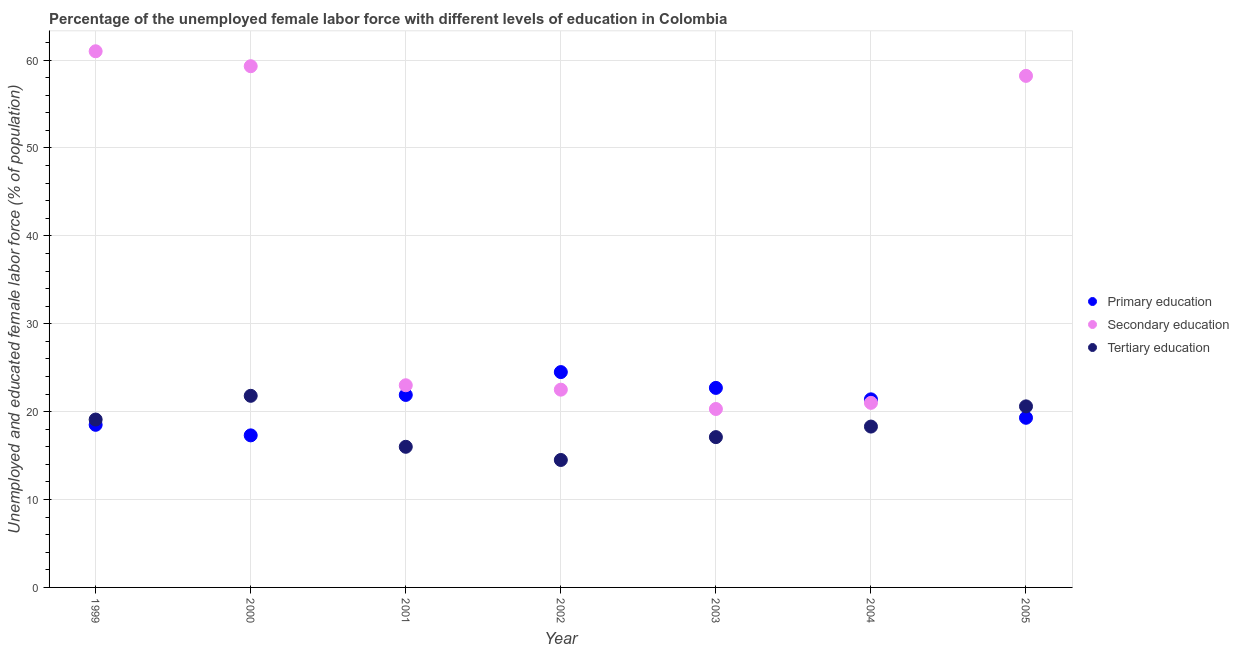How many different coloured dotlines are there?
Provide a succinct answer. 3. Is the number of dotlines equal to the number of legend labels?
Provide a succinct answer. Yes. What is the percentage of female labor force who received tertiary education in 2004?
Ensure brevity in your answer.  18.3. Across all years, what is the minimum percentage of female labor force who received tertiary education?
Give a very brief answer. 14.5. In which year was the percentage of female labor force who received tertiary education minimum?
Offer a terse response. 2002. What is the total percentage of female labor force who received secondary education in the graph?
Ensure brevity in your answer.  265.3. What is the difference between the percentage of female labor force who received secondary education in 2001 and that in 2005?
Provide a succinct answer. -35.2. What is the difference between the percentage of female labor force who received secondary education in 1999 and the percentage of female labor force who received primary education in 2000?
Give a very brief answer. 43.7. What is the average percentage of female labor force who received primary education per year?
Offer a terse response. 20.8. In the year 2004, what is the difference between the percentage of female labor force who received primary education and percentage of female labor force who received tertiary education?
Your answer should be very brief. 3.1. What is the ratio of the percentage of female labor force who received tertiary education in 2000 to that in 2003?
Your answer should be compact. 1.27. What is the difference between the highest and the second highest percentage of female labor force who received tertiary education?
Provide a short and direct response. 1.2. What is the difference between the highest and the lowest percentage of female labor force who received secondary education?
Your answer should be very brief. 40.7. In how many years, is the percentage of female labor force who received secondary education greater than the average percentage of female labor force who received secondary education taken over all years?
Make the answer very short. 3. Is it the case that in every year, the sum of the percentage of female labor force who received primary education and percentage of female labor force who received secondary education is greater than the percentage of female labor force who received tertiary education?
Give a very brief answer. Yes. Is the percentage of female labor force who received secondary education strictly greater than the percentage of female labor force who received tertiary education over the years?
Ensure brevity in your answer.  Yes. How many years are there in the graph?
Your answer should be very brief. 7. Are the values on the major ticks of Y-axis written in scientific E-notation?
Give a very brief answer. No. Does the graph contain any zero values?
Your answer should be compact. No. How many legend labels are there?
Provide a succinct answer. 3. How are the legend labels stacked?
Provide a succinct answer. Vertical. What is the title of the graph?
Give a very brief answer. Percentage of the unemployed female labor force with different levels of education in Colombia. What is the label or title of the Y-axis?
Offer a very short reply. Unemployed and educated female labor force (% of population). What is the Unemployed and educated female labor force (% of population) of Secondary education in 1999?
Give a very brief answer. 61. What is the Unemployed and educated female labor force (% of population) of Tertiary education in 1999?
Offer a terse response. 19.1. What is the Unemployed and educated female labor force (% of population) of Primary education in 2000?
Provide a succinct answer. 17.3. What is the Unemployed and educated female labor force (% of population) in Secondary education in 2000?
Offer a very short reply. 59.3. What is the Unemployed and educated female labor force (% of population) in Tertiary education in 2000?
Keep it short and to the point. 21.8. What is the Unemployed and educated female labor force (% of population) in Primary education in 2001?
Provide a succinct answer. 21.9. What is the Unemployed and educated female labor force (% of population) of Secondary education in 2001?
Ensure brevity in your answer.  23. What is the Unemployed and educated female labor force (% of population) of Tertiary education in 2001?
Offer a terse response. 16. What is the Unemployed and educated female labor force (% of population) in Primary education in 2002?
Keep it short and to the point. 24.5. What is the Unemployed and educated female labor force (% of population) of Secondary education in 2002?
Make the answer very short. 22.5. What is the Unemployed and educated female labor force (% of population) of Tertiary education in 2002?
Give a very brief answer. 14.5. What is the Unemployed and educated female labor force (% of population) in Primary education in 2003?
Offer a terse response. 22.7. What is the Unemployed and educated female labor force (% of population) of Secondary education in 2003?
Your answer should be very brief. 20.3. What is the Unemployed and educated female labor force (% of population) of Tertiary education in 2003?
Offer a very short reply. 17.1. What is the Unemployed and educated female labor force (% of population) of Primary education in 2004?
Keep it short and to the point. 21.4. What is the Unemployed and educated female labor force (% of population) in Secondary education in 2004?
Your response must be concise. 21. What is the Unemployed and educated female labor force (% of population) of Tertiary education in 2004?
Offer a very short reply. 18.3. What is the Unemployed and educated female labor force (% of population) of Primary education in 2005?
Your answer should be compact. 19.3. What is the Unemployed and educated female labor force (% of population) of Secondary education in 2005?
Your answer should be compact. 58.2. What is the Unemployed and educated female labor force (% of population) in Tertiary education in 2005?
Your answer should be compact. 20.6. Across all years, what is the maximum Unemployed and educated female labor force (% of population) of Secondary education?
Offer a very short reply. 61. Across all years, what is the maximum Unemployed and educated female labor force (% of population) of Tertiary education?
Your response must be concise. 21.8. Across all years, what is the minimum Unemployed and educated female labor force (% of population) in Primary education?
Give a very brief answer. 17.3. Across all years, what is the minimum Unemployed and educated female labor force (% of population) in Secondary education?
Offer a very short reply. 20.3. Across all years, what is the minimum Unemployed and educated female labor force (% of population) in Tertiary education?
Ensure brevity in your answer.  14.5. What is the total Unemployed and educated female labor force (% of population) in Primary education in the graph?
Your response must be concise. 145.6. What is the total Unemployed and educated female labor force (% of population) of Secondary education in the graph?
Give a very brief answer. 265.3. What is the total Unemployed and educated female labor force (% of population) in Tertiary education in the graph?
Give a very brief answer. 127.4. What is the difference between the Unemployed and educated female labor force (% of population) of Primary education in 1999 and that in 2000?
Keep it short and to the point. 1.2. What is the difference between the Unemployed and educated female labor force (% of population) in Tertiary education in 1999 and that in 2000?
Provide a succinct answer. -2.7. What is the difference between the Unemployed and educated female labor force (% of population) in Primary education in 1999 and that in 2001?
Offer a terse response. -3.4. What is the difference between the Unemployed and educated female labor force (% of population) in Secondary education in 1999 and that in 2001?
Give a very brief answer. 38. What is the difference between the Unemployed and educated female labor force (% of population) of Secondary education in 1999 and that in 2002?
Keep it short and to the point. 38.5. What is the difference between the Unemployed and educated female labor force (% of population) of Tertiary education in 1999 and that in 2002?
Offer a terse response. 4.6. What is the difference between the Unemployed and educated female labor force (% of population) of Primary education in 1999 and that in 2003?
Offer a very short reply. -4.2. What is the difference between the Unemployed and educated female labor force (% of population) of Secondary education in 1999 and that in 2003?
Ensure brevity in your answer.  40.7. What is the difference between the Unemployed and educated female labor force (% of population) in Tertiary education in 1999 and that in 2004?
Your answer should be compact. 0.8. What is the difference between the Unemployed and educated female labor force (% of population) in Primary education in 2000 and that in 2001?
Make the answer very short. -4.6. What is the difference between the Unemployed and educated female labor force (% of population) of Secondary education in 2000 and that in 2001?
Give a very brief answer. 36.3. What is the difference between the Unemployed and educated female labor force (% of population) of Tertiary education in 2000 and that in 2001?
Provide a short and direct response. 5.8. What is the difference between the Unemployed and educated female labor force (% of population) of Primary education in 2000 and that in 2002?
Ensure brevity in your answer.  -7.2. What is the difference between the Unemployed and educated female labor force (% of population) of Secondary education in 2000 and that in 2002?
Keep it short and to the point. 36.8. What is the difference between the Unemployed and educated female labor force (% of population) of Tertiary education in 2000 and that in 2002?
Give a very brief answer. 7.3. What is the difference between the Unemployed and educated female labor force (% of population) in Primary education in 2000 and that in 2003?
Your response must be concise. -5.4. What is the difference between the Unemployed and educated female labor force (% of population) of Secondary education in 2000 and that in 2003?
Offer a terse response. 39. What is the difference between the Unemployed and educated female labor force (% of population) of Primary education in 2000 and that in 2004?
Give a very brief answer. -4.1. What is the difference between the Unemployed and educated female labor force (% of population) in Secondary education in 2000 and that in 2004?
Ensure brevity in your answer.  38.3. What is the difference between the Unemployed and educated female labor force (% of population) of Tertiary education in 2000 and that in 2004?
Provide a succinct answer. 3.5. What is the difference between the Unemployed and educated female labor force (% of population) in Secondary education in 2000 and that in 2005?
Offer a very short reply. 1.1. What is the difference between the Unemployed and educated female labor force (% of population) of Primary education in 2001 and that in 2002?
Provide a succinct answer. -2.6. What is the difference between the Unemployed and educated female labor force (% of population) in Secondary education in 2001 and that in 2002?
Your answer should be very brief. 0.5. What is the difference between the Unemployed and educated female labor force (% of population) in Secondary education in 2001 and that in 2003?
Your response must be concise. 2.7. What is the difference between the Unemployed and educated female labor force (% of population) of Tertiary education in 2001 and that in 2003?
Offer a very short reply. -1.1. What is the difference between the Unemployed and educated female labor force (% of population) of Primary education in 2001 and that in 2004?
Your answer should be compact. 0.5. What is the difference between the Unemployed and educated female labor force (% of population) in Primary education in 2001 and that in 2005?
Keep it short and to the point. 2.6. What is the difference between the Unemployed and educated female labor force (% of population) in Secondary education in 2001 and that in 2005?
Make the answer very short. -35.2. What is the difference between the Unemployed and educated female labor force (% of population) of Tertiary education in 2001 and that in 2005?
Your answer should be compact. -4.6. What is the difference between the Unemployed and educated female labor force (% of population) in Primary education in 2002 and that in 2003?
Your answer should be very brief. 1.8. What is the difference between the Unemployed and educated female labor force (% of population) of Secondary education in 2002 and that in 2003?
Provide a short and direct response. 2.2. What is the difference between the Unemployed and educated female labor force (% of population) of Secondary education in 2002 and that in 2004?
Provide a short and direct response. 1.5. What is the difference between the Unemployed and educated female labor force (% of population) in Primary education in 2002 and that in 2005?
Offer a terse response. 5.2. What is the difference between the Unemployed and educated female labor force (% of population) of Secondary education in 2002 and that in 2005?
Offer a very short reply. -35.7. What is the difference between the Unemployed and educated female labor force (% of population) in Tertiary education in 2003 and that in 2004?
Your answer should be very brief. -1.2. What is the difference between the Unemployed and educated female labor force (% of population) in Primary education in 2003 and that in 2005?
Keep it short and to the point. 3.4. What is the difference between the Unemployed and educated female labor force (% of population) of Secondary education in 2003 and that in 2005?
Your response must be concise. -37.9. What is the difference between the Unemployed and educated female labor force (% of population) in Tertiary education in 2003 and that in 2005?
Ensure brevity in your answer.  -3.5. What is the difference between the Unemployed and educated female labor force (% of population) of Primary education in 2004 and that in 2005?
Your answer should be compact. 2.1. What is the difference between the Unemployed and educated female labor force (% of population) in Secondary education in 2004 and that in 2005?
Make the answer very short. -37.2. What is the difference between the Unemployed and educated female labor force (% of population) of Tertiary education in 2004 and that in 2005?
Provide a succinct answer. -2.3. What is the difference between the Unemployed and educated female labor force (% of population) in Primary education in 1999 and the Unemployed and educated female labor force (% of population) in Secondary education in 2000?
Offer a terse response. -40.8. What is the difference between the Unemployed and educated female labor force (% of population) in Primary education in 1999 and the Unemployed and educated female labor force (% of population) in Tertiary education in 2000?
Offer a very short reply. -3.3. What is the difference between the Unemployed and educated female labor force (% of population) of Secondary education in 1999 and the Unemployed and educated female labor force (% of population) of Tertiary education in 2000?
Provide a succinct answer. 39.2. What is the difference between the Unemployed and educated female labor force (% of population) in Primary education in 1999 and the Unemployed and educated female labor force (% of population) in Secondary education in 2001?
Provide a succinct answer. -4.5. What is the difference between the Unemployed and educated female labor force (% of population) in Primary education in 1999 and the Unemployed and educated female labor force (% of population) in Tertiary education in 2001?
Offer a very short reply. 2.5. What is the difference between the Unemployed and educated female labor force (% of population) in Primary education in 1999 and the Unemployed and educated female labor force (% of population) in Tertiary education in 2002?
Ensure brevity in your answer.  4. What is the difference between the Unemployed and educated female labor force (% of population) of Secondary education in 1999 and the Unemployed and educated female labor force (% of population) of Tertiary education in 2002?
Provide a short and direct response. 46.5. What is the difference between the Unemployed and educated female labor force (% of population) in Primary education in 1999 and the Unemployed and educated female labor force (% of population) in Secondary education in 2003?
Provide a succinct answer. -1.8. What is the difference between the Unemployed and educated female labor force (% of population) of Secondary education in 1999 and the Unemployed and educated female labor force (% of population) of Tertiary education in 2003?
Keep it short and to the point. 43.9. What is the difference between the Unemployed and educated female labor force (% of population) in Primary education in 1999 and the Unemployed and educated female labor force (% of population) in Tertiary education in 2004?
Your response must be concise. 0.2. What is the difference between the Unemployed and educated female labor force (% of population) in Secondary education in 1999 and the Unemployed and educated female labor force (% of population) in Tertiary education in 2004?
Make the answer very short. 42.7. What is the difference between the Unemployed and educated female labor force (% of population) of Primary education in 1999 and the Unemployed and educated female labor force (% of population) of Secondary education in 2005?
Provide a short and direct response. -39.7. What is the difference between the Unemployed and educated female labor force (% of population) of Primary education in 1999 and the Unemployed and educated female labor force (% of population) of Tertiary education in 2005?
Offer a terse response. -2.1. What is the difference between the Unemployed and educated female labor force (% of population) in Secondary education in 1999 and the Unemployed and educated female labor force (% of population) in Tertiary education in 2005?
Your answer should be very brief. 40.4. What is the difference between the Unemployed and educated female labor force (% of population) of Secondary education in 2000 and the Unemployed and educated female labor force (% of population) of Tertiary education in 2001?
Keep it short and to the point. 43.3. What is the difference between the Unemployed and educated female labor force (% of population) in Primary education in 2000 and the Unemployed and educated female labor force (% of population) in Tertiary education in 2002?
Give a very brief answer. 2.8. What is the difference between the Unemployed and educated female labor force (% of population) in Secondary education in 2000 and the Unemployed and educated female labor force (% of population) in Tertiary education in 2002?
Your response must be concise. 44.8. What is the difference between the Unemployed and educated female labor force (% of population) in Primary education in 2000 and the Unemployed and educated female labor force (% of population) in Tertiary education in 2003?
Your answer should be compact. 0.2. What is the difference between the Unemployed and educated female labor force (% of population) in Secondary education in 2000 and the Unemployed and educated female labor force (% of population) in Tertiary education in 2003?
Offer a very short reply. 42.2. What is the difference between the Unemployed and educated female labor force (% of population) of Primary education in 2000 and the Unemployed and educated female labor force (% of population) of Secondary education in 2004?
Your response must be concise. -3.7. What is the difference between the Unemployed and educated female labor force (% of population) of Primary education in 2000 and the Unemployed and educated female labor force (% of population) of Secondary education in 2005?
Provide a succinct answer. -40.9. What is the difference between the Unemployed and educated female labor force (% of population) in Secondary education in 2000 and the Unemployed and educated female labor force (% of population) in Tertiary education in 2005?
Make the answer very short. 38.7. What is the difference between the Unemployed and educated female labor force (% of population) in Primary education in 2001 and the Unemployed and educated female labor force (% of population) in Secondary education in 2004?
Your answer should be compact. 0.9. What is the difference between the Unemployed and educated female labor force (% of population) in Secondary education in 2001 and the Unemployed and educated female labor force (% of population) in Tertiary education in 2004?
Your response must be concise. 4.7. What is the difference between the Unemployed and educated female labor force (% of population) of Primary education in 2001 and the Unemployed and educated female labor force (% of population) of Secondary education in 2005?
Give a very brief answer. -36.3. What is the difference between the Unemployed and educated female labor force (% of population) in Secondary education in 2001 and the Unemployed and educated female labor force (% of population) in Tertiary education in 2005?
Provide a short and direct response. 2.4. What is the difference between the Unemployed and educated female labor force (% of population) in Primary education in 2002 and the Unemployed and educated female labor force (% of population) in Tertiary education in 2003?
Your answer should be compact. 7.4. What is the difference between the Unemployed and educated female labor force (% of population) in Secondary education in 2002 and the Unemployed and educated female labor force (% of population) in Tertiary education in 2003?
Your answer should be very brief. 5.4. What is the difference between the Unemployed and educated female labor force (% of population) of Primary education in 2002 and the Unemployed and educated female labor force (% of population) of Tertiary education in 2004?
Provide a succinct answer. 6.2. What is the difference between the Unemployed and educated female labor force (% of population) in Primary education in 2002 and the Unemployed and educated female labor force (% of population) in Secondary education in 2005?
Keep it short and to the point. -33.7. What is the difference between the Unemployed and educated female labor force (% of population) in Primary education in 2002 and the Unemployed and educated female labor force (% of population) in Tertiary education in 2005?
Offer a very short reply. 3.9. What is the difference between the Unemployed and educated female labor force (% of population) in Secondary education in 2002 and the Unemployed and educated female labor force (% of population) in Tertiary education in 2005?
Make the answer very short. 1.9. What is the difference between the Unemployed and educated female labor force (% of population) of Primary education in 2003 and the Unemployed and educated female labor force (% of population) of Secondary education in 2004?
Offer a terse response. 1.7. What is the difference between the Unemployed and educated female labor force (% of population) in Primary education in 2003 and the Unemployed and educated female labor force (% of population) in Secondary education in 2005?
Provide a short and direct response. -35.5. What is the difference between the Unemployed and educated female labor force (% of population) in Primary education in 2003 and the Unemployed and educated female labor force (% of population) in Tertiary education in 2005?
Make the answer very short. 2.1. What is the difference between the Unemployed and educated female labor force (% of population) in Primary education in 2004 and the Unemployed and educated female labor force (% of population) in Secondary education in 2005?
Ensure brevity in your answer.  -36.8. What is the difference between the Unemployed and educated female labor force (% of population) in Secondary education in 2004 and the Unemployed and educated female labor force (% of population) in Tertiary education in 2005?
Offer a terse response. 0.4. What is the average Unemployed and educated female labor force (% of population) of Primary education per year?
Offer a very short reply. 20.8. What is the average Unemployed and educated female labor force (% of population) of Secondary education per year?
Your answer should be very brief. 37.9. What is the average Unemployed and educated female labor force (% of population) of Tertiary education per year?
Keep it short and to the point. 18.2. In the year 1999, what is the difference between the Unemployed and educated female labor force (% of population) in Primary education and Unemployed and educated female labor force (% of population) in Secondary education?
Give a very brief answer. -42.5. In the year 1999, what is the difference between the Unemployed and educated female labor force (% of population) in Secondary education and Unemployed and educated female labor force (% of population) in Tertiary education?
Give a very brief answer. 41.9. In the year 2000, what is the difference between the Unemployed and educated female labor force (% of population) in Primary education and Unemployed and educated female labor force (% of population) in Secondary education?
Give a very brief answer. -42. In the year 2000, what is the difference between the Unemployed and educated female labor force (% of population) in Primary education and Unemployed and educated female labor force (% of population) in Tertiary education?
Provide a short and direct response. -4.5. In the year 2000, what is the difference between the Unemployed and educated female labor force (% of population) in Secondary education and Unemployed and educated female labor force (% of population) in Tertiary education?
Keep it short and to the point. 37.5. In the year 2001, what is the difference between the Unemployed and educated female labor force (% of population) of Primary education and Unemployed and educated female labor force (% of population) of Tertiary education?
Your answer should be compact. 5.9. In the year 2001, what is the difference between the Unemployed and educated female labor force (% of population) of Secondary education and Unemployed and educated female labor force (% of population) of Tertiary education?
Your response must be concise. 7. In the year 2002, what is the difference between the Unemployed and educated female labor force (% of population) in Primary education and Unemployed and educated female labor force (% of population) in Tertiary education?
Your response must be concise. 10. In the year 2003, what is the difference between the Unemployed and educated female labor force (% of population) in Secondary education and Unemployed and educated female labor force (% of population) in Tertiary education?
Provide a short and direct response. 3.2. In the year 2004, what is the difference between the Unemployed and educated female labor force (% of population) in Primary education and Unemployed and educated female labor force (% of population) in Secondary education?
Provide a succinct answer. 0.4. In the year 2004, what is the difference between the Unemployed and educated female labor force (% of population) of Primary education and Unemployed and educated female labor force (% of population) of Tertiary education?
Your answer should be very brief. 3.1. In the year 2005, what is the difference between the Unemployed and educated female labor force (% of population) in Primary education and Unemployed and educated female labor force (% of population) in Secondary education?
Your answer should be very brief. -38.9. In the year 2005, what is the difference between the Unemployed and educated female labor force (% of population) in Secondary education and Unemployed and educated female labor force (% of population) in Tertiary education?
Ensure brevity in your answer.  37.6. What is the ratio of the Unemployed and educated female labor force (% of population) in Primary education in 1999 to that in 2000?
Make the answer very short. 1.07. What is the ratio of the Unemployed and educated female labor force (% of population) in Secondary education in 1999 to that in 2000?
Give a very brief answer. 1.03. What is the ratio of the Unemployed and educated female labor force (% of population) in Tertiary education in 1999 to that in 2000?
Give a very brief answer. 0.88. What is the ratio of the Unemployed and educated female labor force (% of population) of Primary education in 1999 to that in 2001?
Make the answer very short. 0.84. What is the ratio of the Unemployed and educated female labor force (% of population) in Secondary education in 1999 to that in 2001?
Provide a succinct answer. 2.65. What is the ratio of the Unemployed and educated female labor force (% of population) of Tertiary education in 1999 to that in 2001?
Your answer should be compact. 1.19. What is the ratio of the Unemployed and educated female labor force (% of population) of Primary education in 1999 to that in 2002?
Keep it short and to the point. 0.76. What is the ratio of the Unemployed and educated female labor force (% of population) of Secondary education in 1999 to that in 2002?
Offer a very short reply. 2.71. What is the ratio of the Unemployed and educated female labor force (% of population) in Tertiary education in 1999 to that in 2002?
Keep it short and to the point. 1.32. What is the ratio of the Unemployed and educated female labor force (% of population) in Primary education in 1999 to that in 2003?
Your answer should be very brief. 0.81. What is the ratio of the Unemployed and educated female labor force (% of population) in Secondary education in 1999 to that in 2003?
Ensure brevity in your answer.  3. What is the ratio of the Unemployed and educated female labor force (% of population) of Tertiary education in 1999 to that in 2003?
Your answer should be compact. 1.12. What is the ratio of the Unemployed and educated female labor force (% of population) of Primary education in 1999 to that in 2004?
Offer a very short reply. 0.86. What is the ratio of the Unemployed and educated female labor force (% of population) in Secondary education in 1999 to that in 2004?
Keep it short and to the point. 2.9. What is the ratio of the Unemployed and educated female labor force (% of population) of Tertiary education in 1999 to that in 2004?
Ensure brevity in your answer.  1.04. What is the ratio of the Unemployed and educated female labor force (% of population) in Primary education in 1999 to that in 2005?
Keep it short and to the point. 0.96. What is the ratio of the Unemployed and educated female labor force (% of population) of Secondary education in 1999 to that in 2005?
Keep it short and to the point. 1.05. What is the ratio of the Unemployed and educated female labor force (% of population) in Tertiary education in 1999 to that in 2005?
Your answer should be very brief. 0.93. What is the ratio of the Unemployed and educated female labor force (% of population) of Primary education in 2000 to that in 2001?
Give a very brief answer. 0.79. What is the ratio of the Unemployed and educated female labor force (% of population) of Secondary education in 2000 to that in 2001?
Offer a very short reply. 2.58. What is the ratio of the Unemployed and educated female labor force (% of population) of Tertiary education in 2000 to that in 2001?
Provide a short and direct response. 1.36. What is the ratio of the Unemployed and educated female labor force (% of population) in Primary education in 2000 to that in 2002?
Provide a succinct answer. 0.71. What is the ratio of the Unemployed and educated female labor force (% of population) of Secondary education in 2000 to that in 2002?
Provide a succinct answer. 2.64. What is the ratio of the Unemployed and educated female labor force (% of population) of Tertiary education in 2000 to that in 2002?
Your response must be concise. 1.5. What is the ratio of the Unemployed and educated female labor force (% of population) in Primary education in 2000 to that in 2003?
Make the answer very short. 0.76. What is the ratio of the Unemployed and educated female labor force (% of population) in Secondary education in 2000 to that in 2003?
Your response must be concise. 2.92. What is the ratio of the Unemployed and educated female labor force (% of population) in Tertiary education in 2000 to that in 2003?
Give a very brief answer. 1.27. What is the ratio of the Unemployed and educated female labor force (% of population) in Primary education in 2000 to that in 2004?
Ensure brevity in your answer.  0.81. What is the ratio of the Unemployed and educated female labor force (% of population) of Secondary education in 2000 to that in 2004?
Offer a terse response. 2.82. What is the ratio of the Unemployed and educated female labor force (% of population) in Tertiary education in 2000 to that in 2004?
Your answer should be very brief. 1.19. What is the ratio of the Unemployed and educated female labor force (% of population) of Primary education in 2000 to that in 2005?
Keep it short and to the point. 0.9. What is the ratio of the Unemployed and educated female labor force (% of population) of Secondary education in 2000 to that in 2005?
Make the answer very short. 1.02. What is the ratio of the Unemployed and educated female labor force (% of population) of Tertiary education in 2000 to that in 2005?
Keep it short and to the point. 1.06. What is the ratio of the Unemployed and educated female labor force (% of population) in Primary education in 2001 to that in 2002?
Offer a very short reply. 0.89. What is the ratio of the Unemployed and educated female labor force (% of population) in Secondary education in 2001 to that in 2002?
Make the answer very short. 1.02. What is the ratio of the Unemployed and educated female labor force (% of population) in Tertiary education in 2001 to that in 2002?
Make the answer very short. 1.1. What is the ratio of the Unemployed and educated female labor force (% of population) of Primary education in 2001 to that in 2003?
Make the answer very short. 0.96. What is the ratio of the Unemployed and educated female labor force (% of population) of Secondary education in 2001 to that in 2003?
Your response must be concise. 1.13. What is the ratio of the Unemployed and educated female labor force (% of population) in Tertiary education in 2001 to that in 2003?
Keep it short and to the point. 0.94. What is the ratio of the Unemployed and educated female labor force (% of population) in Primary education in 2001 to that in 2004?
Your answer should be compact. 1.02. What is the ratio of the Unemployed and educated female labor force (% of population) in Secondary education in 2001 to that in 2004?
Offer a very short reply. 1.1. What is the ratio of the Unemployed and educated female labor force (% of population) of Tertiary education in 2001 to that in 2004?
Make the answer very short. 0.87. What is the ratio of the Unemployed and educated female labor force (% of population) of Primary education in 2001 to that in 2005?
Your answer should be very brief. 1.13. What is the ratio of the Unemployed and educated female labor force (% of population) in Secondary education in 2001 to that in 2005?
Your answer should be compact. 0.4. What is the ratio of the Unemployed and educated female labor force (% of population) of Tertiary education in 2001 to that in 2005?
Give a very brief answer. 0.78. What is the ratio of the Unemployed and educated female labor force (% of population) in Primary education in 2002 to that in 2003?
Make the answer very short. 1.08. What is the ratio of the Unemployed and educated female labor force (% of population) of Secondary education in 2002 to that in 2003?
Give a very brief answer. 1.11. What is the ratio of the Unemployed and educated female labor force (% of population) in Tertiary education in 2002 to that in 2003?
Give a very brief answer. 0.85. What is the ratio of the Unemployed and educated female labor force (% of population) in Primary education in 2002 to that in 2004?
Provide a short and direct response. 1.14. What is the ratio of the Unemployed and educated female labor force (% of population) of Secondary education in 2002 to that in 2004?
Provide a succinct answer. 1.07. What is the ratio of the Unemployed and educated female labor force (% of population) of Tertiary education in 2002 to that in 2004?
Offer a very short reply. 0.79. What is the ratio of the Unemployed and educated female labor force (% of population) in Primary education in 2002 to that in 2005?
Provide a succinct answer. 1.27. What is the ratio of the Unemployed and educated female labor force (% of population) of Secondary education in 2002 to that in 2005?
Your answer should be compact. 0.39. What is the ratio of the Unemployed and educated female labor force (% of population) in Tertiary education in 2002 to that in 2005?
Give a very brief answer. 0.7. What is the ratio of the Unemployed and educated female labor force (% of population) of Primary education in 2003 to that in 2004?
Make the answer very short. 1.06. What is the ratio of the Unemployed and educated female labor force (% of population) in Secondary education in 2003 to that in 2004?
Provide a succinct answer. 0.97. What is the ratio of the Unemployed and educated female labor force (% of population) of Tertiary education in 2003 to that in 2004?
Your response must be concise. 0.93. What is the ratio of the Unemployed and educated female labor force (% of population) of Primary education in 2003 to that in 2005?
Offer a very short reply. 1.18. What is the ratio of the Unemployed and educated female labor force (% of population) of Secondary education in 2003 to that in 2005?
Make the answer very short. 0.35. What is the ratio of the Unemployed and educated female labor force (% of population) of Tertiary education in 2003 to that in 2005?
Your answer should be very brief. 0.83. What is the ratio of the Unemployed and educated female labor force (% of population) in Primary education in 2004 to that in 2005?
Provide a succinct answer. 1.11. What is the ratio of the Unemployed and educated female labor force (% of population) of Secondary education in 2004 to that in 2005?
Keep it short and to the point. 0.36. What is the ratio of the Unemployed and educated female labor force (% of population) of Tertiary education in 2004 to that in 2005?
Make the answer very short. 0.89. What is the difference between the highest and the second highest Unemployed and educated female labor force (% of population) in Secondary education?
Your response must be concise. 1.7. What is the difference between the highest and the lowest Unemployed and educated female labor force (% of population) in Secondary education?
Offer a very short reply. 40.7. What is the difference between the highest and the lowest Unemployed and educated female labor force (% of population) of Tertiary education?
Your response must be concise. 7.3. 